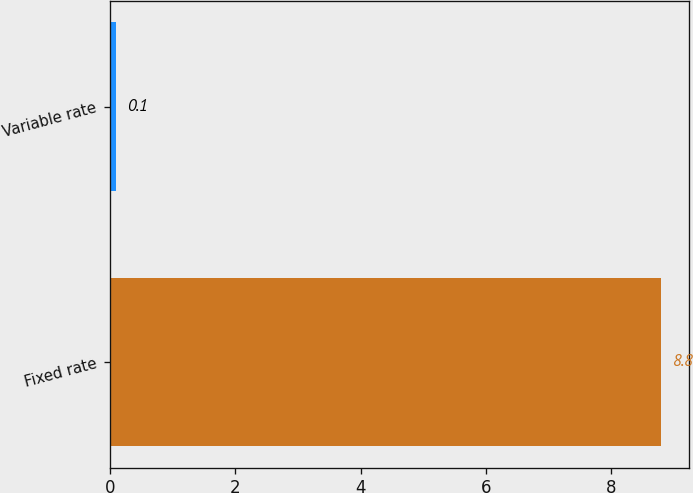Convert chart to OTSL. <chart><loc_0><loc_0><loc_500><loc_500><bar_chart><fcel>Fixed rate<fcel>Variable rate<nl><fcel>8.8<fcel>0.1<nl></chart> 